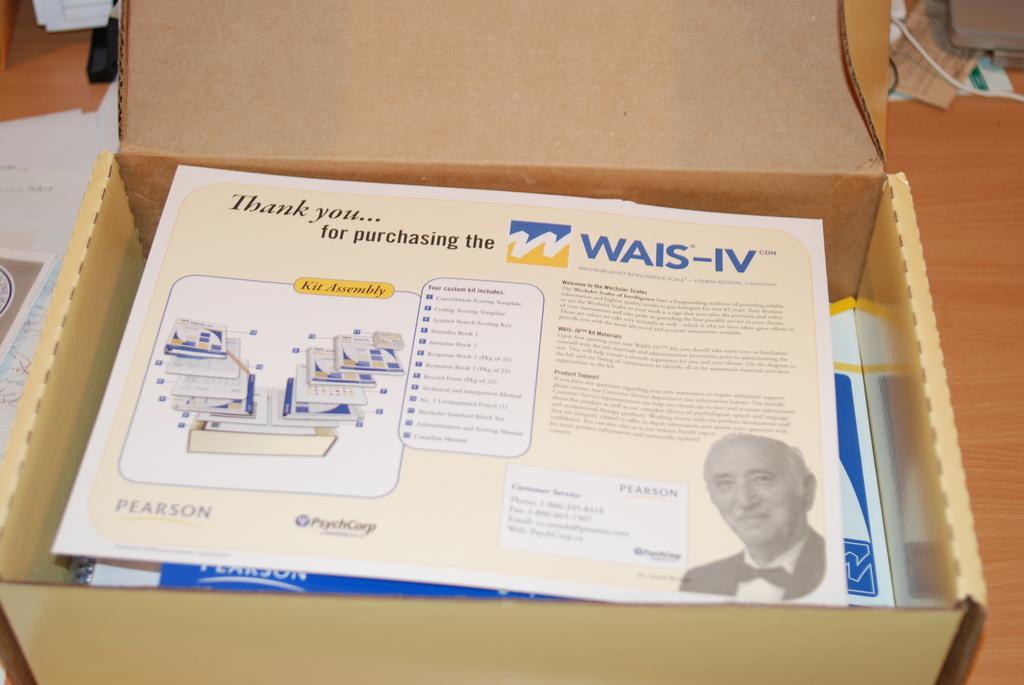Describe this image in one or two sentences. There is a box with some papers. On the paper there is something written also there is an image of a person. On the floor there are many other items. 